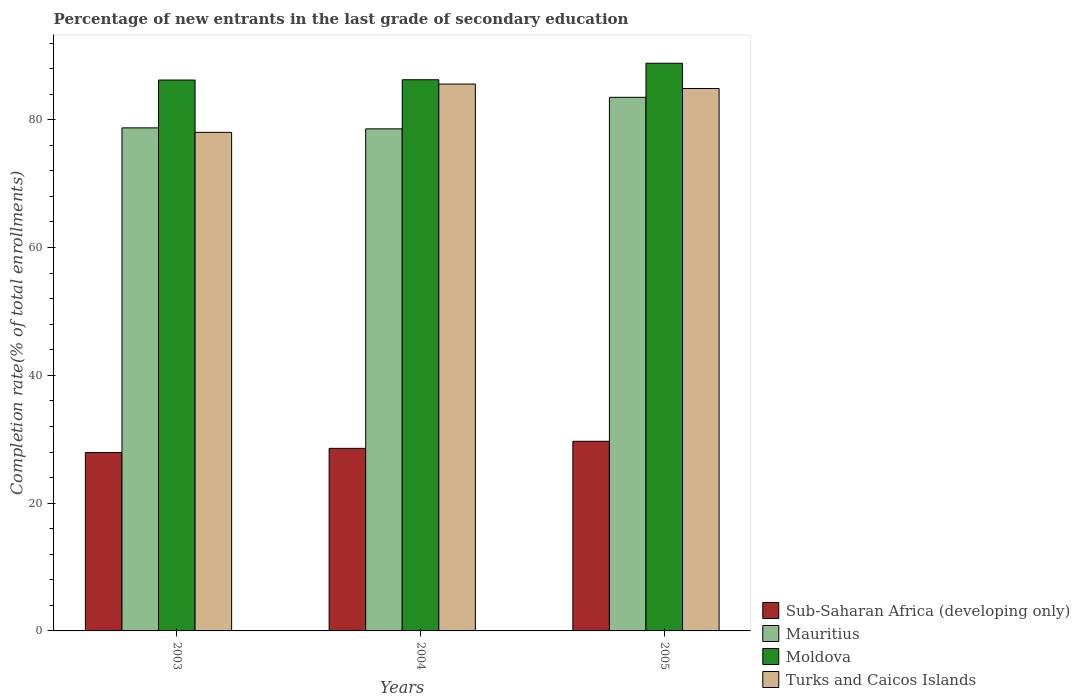Are the number of bars on each tick of the X-axis equal?
Ensure brevity in your answer.  Yes. How many bars are there on the 1st tick from the left?
Give a very brief answer. 4. What is the label of the 1st group of bars from the left?
Your answer should be very brief. 2003. What is the percentage of new entrants in Turks and Caicos Islands in 2004?
Ensure brevity in your answer.  85.59. Across all years, what is the maximum percentage of new entrants in Turks and Caicos Islands?
Make the answer very short. 85.59. Across all years, what is the minimum percentage of new entrants in Mauritius?
Offer a very short reply. 78.57. In which year was the percentage of new entrants in Sub-Saharan Africa (developing only) minimum?
Offer a terse response. 2003. What is the total percentage of new entrants in Sub-Saharan Africa (developing only) in the graph?
Offer a terse response. 86.17. What is the difference between the percentage of new entrants in Moldova in 2003 and that in 2005?
Keep it short and to the point. -2.63. What is the difference between the percentage of new entrants in Sub-Saharan Africa (developing only) in 2005 and the percentage of new entrants in Mauritius in 2004?
Offer a very short reply. -48.9. What is the average percentage of new entrants in Turks and Caicos Islands per year?
Your answer should be very brief. 82.83. In the year 2005, what is the difference between the percentage of new entrants in Sub-Saharan Africa (developing only) and percentage of new entrants in Moldova?
Your answer should be compact. -59.16. What is the ratio of the percentage of new entrants in Turks and Caicos Islands in 2003 to that in 2004?
Your answer should be very brief. 0.91. Is the difference between the percentage of new entrants in Sub-Saharan Africa (developing only) in 2004 and 2005 greater than the difference between the percentage of new entrants in Moldova in 2004 and 2005?
Your answer should be compact. Yes. What is the difference between the highest and the second highest percentage of new entrants in Sub-Saharan Africa (developing only)?
Offer a very short reply. 1.1. What is the difference between the highest and the lowest percentage of new entrants in Sub-Saharan Africa (developing only)?
Provide a short and direct response. 1.76. Is it the case that in every year, the sum of the percentage of new entrants in Sub-Saharan Africa (developing only) and percentage of new entrants in Turks and Caicos Islands is greater than the sum of percentage of new entrants in Moldova and percentage of new entrants in Mauritius?
Your response must be concise. No. What does the 3rd bar from the left in 2005 represents?
Provide a short and direct response. Moldova. What does the 1st bar from the right in 2003 represents?
Your answer should be very brief. Turks and Caicos Islands. Is it the case that in every year, the sum of the percentage of new entrants in Sub-Saharan Africa (developing only) and percentage of new entrants in Moldova is greater than the percentage of new entrants in Mauritius?
Ensure brevity in your answer.  Yes. How many bars are there?
Provide a succinct answer. 12. Are all the bars in the graph horizontal?
Give a very brief answer. No. Are the values on the major ticks of Y-axis written in scientific E-notation?
Provide a succinct answer. No. Does the graph contain any zero values?
Give a very brief answer. No. Does the graph contain grids?
Your answer should be compact. No. What is the title of the graph?
Offer a terse response. Percentage of new entrants in the last grade of secondary education. Does "Central African Republic" appear as one of the legend labels in the graph?
Provide a short and direct response. No. What is the label or title of the Y-axis?
Ensure brevity in your answer.  Completion rate(% of total enrollments). What is the Completion rate(% of total enrollments) in Sub-Saharan Africa (developing only) in 2003?
Your response must be concise. 27.92. What is the Completion rate(% of total enrollments) in Mauritius in 2003?
Give a very brief answer. 78.73. What is the Completion rate(% of total enrollments) of Moldova in 2003?
Ensure brevity in your answer.  86.21. What is the Completion rate(% of total enrollments) of Turks and Caicos Islands in 2003?
Your response must be concise. 78.03. What is the Completion rate(% of total enrollments) in Sub-Saharan Africa (developing only) in 2004?
Provide a succinct answer. 28.57. What is the Completion rate(% of total enrollments) of Mauritius in 2004?
Your answer should be very brief. 78.57. What is the Completion rate(% of total enrollments) in Moldova in 2004?
Provide a short and direct response. 86.26. What is the Completion rate(% of total enrollments) of Turks and Caicos Islands in 2004?
Your answer should be compact. 85.59. What is the Completion rate(% of total enrollments) in Sub-Saharan Africa (developing only) in 2005?
Offer a terse response. 29.68. What is the Completion rate(% of total enrollments) of Mauritius in 2005?
Make the answer very short. 83.51. What is the Completion rate(% of total enrollments) in Moldova in 2005?
Your answer should be compact. 88.84. What is the Completion rate(% of total enrollments) of Turks and Caicos Islands in 2005?
Your response must be concise. 84.89. Across all years, what is the maximum Completion rate(% of total enrollments) of Sub-Saharan Africa (developing only)?
Your answer should be very brief. 29.68. Across all years, what is the maximum Completion rate(% of total enrollments) in Mauritius?
Make the answer very short. 83.51. Across all years, what is the maximum Completion rate(% of total enrollments) in Moldova?
Ensure brevity in your answer.  88.84. Across all years, what is the maximum Completion rate(% of total enrollments) of Turks and Caicos Islands?
Offer a terse response. 85.59. Across all years, what is the minimum Completion rate(% of total enrollments) in Sub-Saharan Africa (developing only)?
Provide a succinct answer. 27.92. Across all years, what is the minimum Completion rate(% of total enrollments) of Mauritius?
Offer a very short reply. 78.57. Across all years, what is the minimum Completion rate(% of total enrollments) in Moldova?
Offer a terse response. 86.21. Across all years, what is the minimum Completion rate(% of total enrollments) in Turks and Caicos Islands?
Keep it short and to the point. 78.03. What is the total Completion rate(% of total enrollments) of Sub-Saharan Africa (developing only) in the graph?
Make the answer very short. 86.17. What is the total Completion rate(% of total enrollments) of Mauritius in the graph?
Provide a short and direct response. 240.81. What is the total Completion rate(% of total enrollments) of Moldova in the graph?
Provide a succinct answer. 261.31. What is the total Completion rate(% of total enrollments) in Turks and Caicos Islands in the graph?
Provide a succinct answer. 248.5. What is the difference between the Completion rate(% of total enrollments) in Sub-Saharan Africa (developing only) in 2003 and that in 2004?
Ensure brevity in your answer.  -0.66. What is the difference between the Completion rate(% of total enrollments) in Mauritius in 2003 and that in 2004?
Offer a very short reply. 0.15. What is the difference between the Completion rate(% of total enrollments) in Moldova in 2003 and that in 2004?
Offer a very short reply. -0.05. What is the difference between the Completion rate(% of total enrollments) of Turks and Caicos Islands in 2003 and that in 2004?
Offer a terse response. -7.56. What is the difference between the Completion rate(% of total enrollments) of Sub-Saharan Africa (developing only) in 2003 and that in 2005?
Make the answer very short. -1.76. What is the difference between the Completion rate(% of total enrollments) in Mauritius in 2003 and that in 2005?
Offer a terse response. -4.78. What is the difference between the Completion rate(% of total enrollments) of Moldova in 2003 and that in 2005?
Make the answer very short. -2.63. What is the difference between the Completion rate(% of total enrollments) in Turks and Caicos Islands in 2003 and that in 2005?
Ensure brevity in your answer.  -6.86. What is the difference between the Completion rate(% of total enrollments) in Sub-Saharan Africa (developing only) in 2004 and that in 2005?
Your answer should be compact. -1.1. What is the difference between the Completion rate(% of total enrollments) in Mauritius in 2004 and that in 2005?
Offer a very short reply. -4.94. What is the difference between the Completion rate(% of total enrollments) of Moldova in 2004 and that in 2005?
Your answer should be very brief. -2.58. What is the difference between the Completion rate(% of total enrollments) in Turks and Caicos Islands in 2004 and that in 2005?
Make the answer very short. 0.7. What is the difference between the Completion rate(% of total enrollments) in Sub-Saharan Africa (developing only) in 2003 and the Completion rate(% of total enrollments) in Mauritius in 2004?
Your answer should be compact. -50.66. What is the difference between the Completion rate(% of total enrollments) in Sub-Saharan Africa (developing only) in 2003 and the Completion rate(% of total enrollments) in Moldova in 2004?
Your answer should be very brief. -58.34. What is the difference between the Completion rate(% of total enrollments) in Sub-Saharan Africa (developing only) in 2003 and the Completion rate(% of total enrollments) in Turks and Caicos Islands in 2004?
Offer a very short reply. -57.67. What is the difference between the Completion rate(% of total enrollments) in Mauritius in 2003 and the Completion rate(% of total enrollments) in Moldova in 2004?
Your answer should be compact. -7.53. What is the difference between the Completion rate(% of total enrollments) in Mauritius in 2003 and the Completion rate(% of total enrollments) in Turks and Caicos Islands in 2004?
Provide a short and direct response. -6.86. What is the difference between the Completion rate(% of total enrollments) in Moldova in 2003 and the Completion rate(% of total enrollments) in Turks and Caicos Islands in 2004?
Your response must be concise. 0.63. What is the difference between the Completion rate(% of total enrollments) in Sub-Saharan Africa (developing only) in 2003 and the Completion rate(% of total enrollments) in Mauritius in 2005?
Make the answer very short. -55.59. What is the difference between the Completion rate(% of total enrollments) of Sub-Saharan Africa (developing only) in 2003 and the Completion rate(% of total enrollments) of Moldova in 2005?
Your response must be concise. -60.92. What is the difference between the Completion rate(% of total enrollments) of Sub-Saharan Africa (developing only) in 2003 and the Completion rate(% of total enrollments) of Turks and Caicos Islands in 2005?
Provide a short and direct response. -56.97. What is the difference between the Completion rate(% of total enrollments) of Mauritius in 2003 and the Completion rate(% of total enrollments) of Moldova in 2005?
Provide a succinct answer. -10.11. What is the difference between the Completion rate(% of total enrollments) in Mauritius in 2003 and the Completion rate(% of total enrollments) in Turks and Caicos Islands in 2005?
Ensure brevity in your answer.  -6.16. What is the difference between the Completion rate(% of total enrollments) of Moldova in 2003 and the Completion rate(% of total enrollments) of Turks and Caicos Islands in 2005?
Make the answer very short. 1.32. What is the difference between the Completion rate(% of total enrollments) of Sub-Saharan Africa (developing only) in 2004 and the Completion rate(% of total enrollments) of Mauritius in 2005?
Provide a short and direct response. -54.94. What is the difference between the Completion rate(% of total enrollments) in Sub-Saharan Africa (developing only) in 2004 and the Completion rate(% of total enrollments) in Moldova in 2005?
Your response must be concise. -60.27. What is the difference between the Completion rate(% of total enrollments) in Sub-Saharan Africa (developing only) in 2004 and the Completion rate(% of total enrollments) in Turks and Caicos Islands in 2005?
Ensure brevity in your answer.  -56.32. What is the difference between the Completion rate(% of total enrollments) of Mauritius in 2004 and the Completion rate(% of total enrollments) of Moldova in 2005?
Your answer should be very brief. -10.27. What is the difference between the Completion rate(% of total enrollments) of Mauritius in 2004 and the Completion rate(% of total enrollments) of Turks and Caicos Islands in 2005?
Make the answer very short. -6.32. What is the difference between the Completion rate(% of total enrollments) of Moldova in 2004 and the Completion rate(% of total enrollments) of Turks and Caicos Islands in 2005?
Keep it short and to the point. 1.37. What is the average Completion rate(% of total enrollments) of Sub-Saharan Africa (developing only) per year?
Your response must be concise. 28.72. What is the average Completion rate(% of total enrollments) in Mauritius per year?
Make the answer very short. 80.27. What is the average Completion rate(% of total enrollments) in Moldova per year?
Your answer should be compact. 87.1. What is the average Completion rate(% of total enrollments) in Turks and Caicos Islands per year?
Offer a very short reply. 82.83. In the year 2003, what is the difference between the Completion rate(% of total enrollments) of Sub-Saharan Africa (developing only) and Completion rate(% of total enrollments) of Mauritius?
Your answer should be very brief. -50.81. In the year 2003, what is the difference between the Completion rate(% of total enrollments) of Sub-Saharan Africa (developing only) and Completion rate(% of total enrollments) of Moldova?
Ensure brevity in your answer.  -58.3. In the year 2003, what is the difference between the Completion rate(% of total enrollments) of Sub-Saharan Africa (developing only) and Completion rate(% of total enrollments) of Turks and Caicos Islands?
Provide a short and direct response. -50.11. In the year 2003, what is the difference between the Completion rate(% of total enrollments) of Mauritius and Completion rate(% of total enrollments) of Moldova?
Provide a short and direct response. -7.49. In the year 2003, what is the difference between the Completion rate(% of total enrollments) of Mauritius and Completion rate(% of total enrollments) of Turks and Caicos Islands?
Give a very brief answer. 0.7. In the year 2003, what is the difference between the Completion rate(% of total enrollments) of Moldova and Completion rate(% of total enrollments) of Turks and Caicos Islands?
Make the answer very short. 8.19. In the year 2004, what is the difference between the Completion rate(% of total enrollments) in Sub-Saharan Africa (developing only) and Completion rate(% of total enrollments) in Mauritius?
Provide a short and direct response. -50. In the year 2004, what is the difference between the Completion rate(% of total enrollments) in Sub-Saharan Africa (developing only) and Completion rate(% of total enrollments) in Moldova?
Make the answer very short. -57.69. In the year 2004, what is the difference between the Completion rate(% of total enrollments) in Sub-Saharan Africa (developing only) and Completion rate(% of total enrollments) in Turks and Caicos Islands?
Make the answer very short. -57.01. In the year 2004, what is the difference between the Completion rate(% of total enrollments) of Mauritius and Completion rate(% of total enrollments) of Moldova?
Ensure brevity in your answer.  -7.69. In the year 2004, what is the difference between the Completion rate(% of total enrollments) of Mauritius and Completion rate(% of total enrollments) of Turks and Caicos Islands?
Make the answer very short. -7.01. In the year 2004, what is the difference between the Completion rate(% of total enrollments) in Moldova and Completion rate(% of total enrollments) in Turks and Caicos Islands?
Offer a terse response. 0.67. In the year 2005, what is the difference between the Completion rate(% of total enrollments) in Sub-Saharan Africa (developing only) and Completion rate(% of total enrollments) in Mauritius?
Your response must be concise. -53.83. In the year 2005, what is the difference between the Completion rate(% of total enrollments) of Sub-Saharan Africa (developing only) and Completion rate(% of total enrollments) of Moldova?
Keep it short and to the point. -59.16. In the year 2005, what is the difference between the Completion rate(% of total enrollments) of Sub-Saharan Africa (developing only) and Completion rate(% of total enrollments) of Turks and Caicos Islands?
Offer a terse response. -55.21. In the year 2005, what is the difference between the Completion rate(% of total enrollments) in Mauritius and Completion rate(% of total enrollments) in Moldova?
Provide a succinct answer. -5.33. In the year 2005, what is the difference between the Completion rate(% of total enrollments) in Mauritius and Completion rate(% of total enrollments) in Turks and Caicos Islands?
Provide a short and direct response. -1.38. In the year 2005, what is the difference between the Completion rate(% of total enrollments) of Moldova and Completion rate(% of total enrollments) of Turks and Caicos Islands?
Keep it short and to the point. 3.95. What is the ratio of the Completion rate(% of total enrollments) of Turks and Caicos Islands in 2003 to that in 2004?
Your answer should be very brief. 0.91. What is the ratio of the Completion rate(% of total enrollments) in Sub-Saharan Africa (developing only) in 2003 to that in 2005?
Offer a very short reply. 0.94. What is the ratio of the Completion rate(% of total enrollments) of Mauritius in 2003 to that in 2005?
Provide a succinct answer. 0.94. What is the ratio of the Completion rate(% of total enrollments) in Moldova in 2003 to that in 2005?
Keep it short and to the point. 0.97. What is the ratio of the Completion rate(% of total enrollments) in Turks and Caicos Islands in 2003 to that in 2005?
Your answer should be compact. 0.92. What is the ratio of the Completion rate(% of total enrollments) in Sub-Saharan Africa (developing only) in 2004 to that in 2005?
Keep it short and to the point. 0.96. What is the ratio of the Completion rate(% of total enrollments) of Mauritius in 2004 to that in 2005?
Keep it short and to the point. 0.94. What is the ratio of the Completion rate(% of total enrollments) of Moldova in 2004 to that in 2005?
Make the answer very short. 0.97. What is the ratio of the Completion rate(% of total enrollments) in Turks and Caicos Islands in 2004 to that in 2005?
Offer a terse response. 1.01. What is the difference between the highest and the second highest Completion rate(% of total enrollments) of Sub-Saharan Africa (developing only)?
Keep it short and to the point. 1.1. What is the difference between the highest and the second highest Completion rate(% of total enrollments) of Mauritius?
Make the answer very short. 4.78. What is the difference between the highest and the second highest Completion rate(% of total enrollments) of Moldova?
Offer a terse response. 2.58. What is the difference between the highest and the second highest Completion rate(% of total enrollments) of Turks and Caicos Islands?
Your answer should be compact. 0.7. What is the difference between the highest and the lowest Completion rate(% of total enrollments) in Sub-Saharan Africa (developing only)?
Keep it short and to the point. 1.76. What is the difference between the highest and the lowest Completion rate(% of total enrollments) in Mauritius?
Give a very brief answer. 4.94. What is the difference between the highest and the lowest Completion rate(% of total enrollments) of Moldova?
Keep it short and to the point. 2.63. What is the difference between the highest and the lowest Completion rate(% of total enrollments) in Turks and Caicos Islands?
Keep it short and to the point. 7.56. 